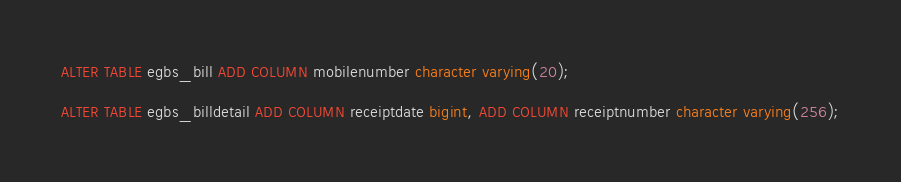<code> <loc_0><loc_0><loc_500><loc_500><_SQL_>ALTER TABLE egbs_bill ADD COLUMN mobilenumber character varying(20);

ALTER TABLE egbs_billdetail ADD COLUMN receiptdate bigint, ADD COLUMN receiptnumber character varying(256);
</code> 